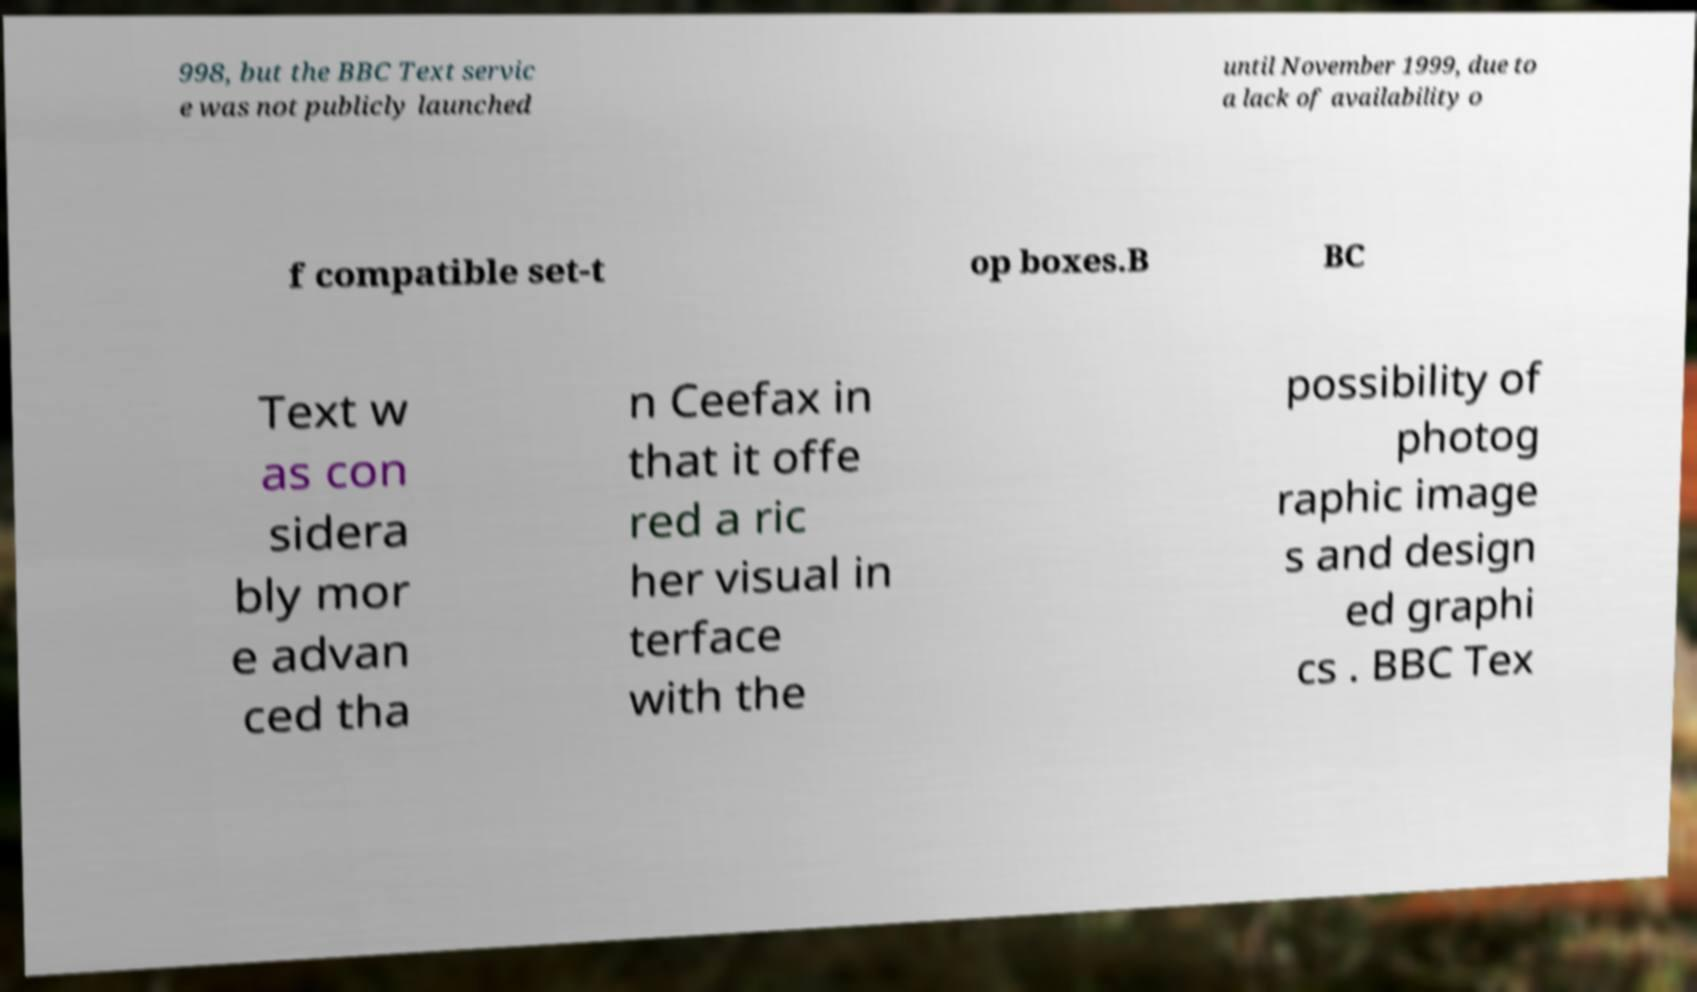There's text embedded in this image that I need extracted. Can you transcribe it verbatim? 998, but the BBC Text servic e was not publicly launched until November 1999, due to a lack of availability o f compatible set-t op boxes.B BC Text w as con sidera bly mor e advan ced tha n Ceefax in that it offe red a ric her visual in terface with the possibility of photog raphic image s and design ed graphi cs . BBC Tex 